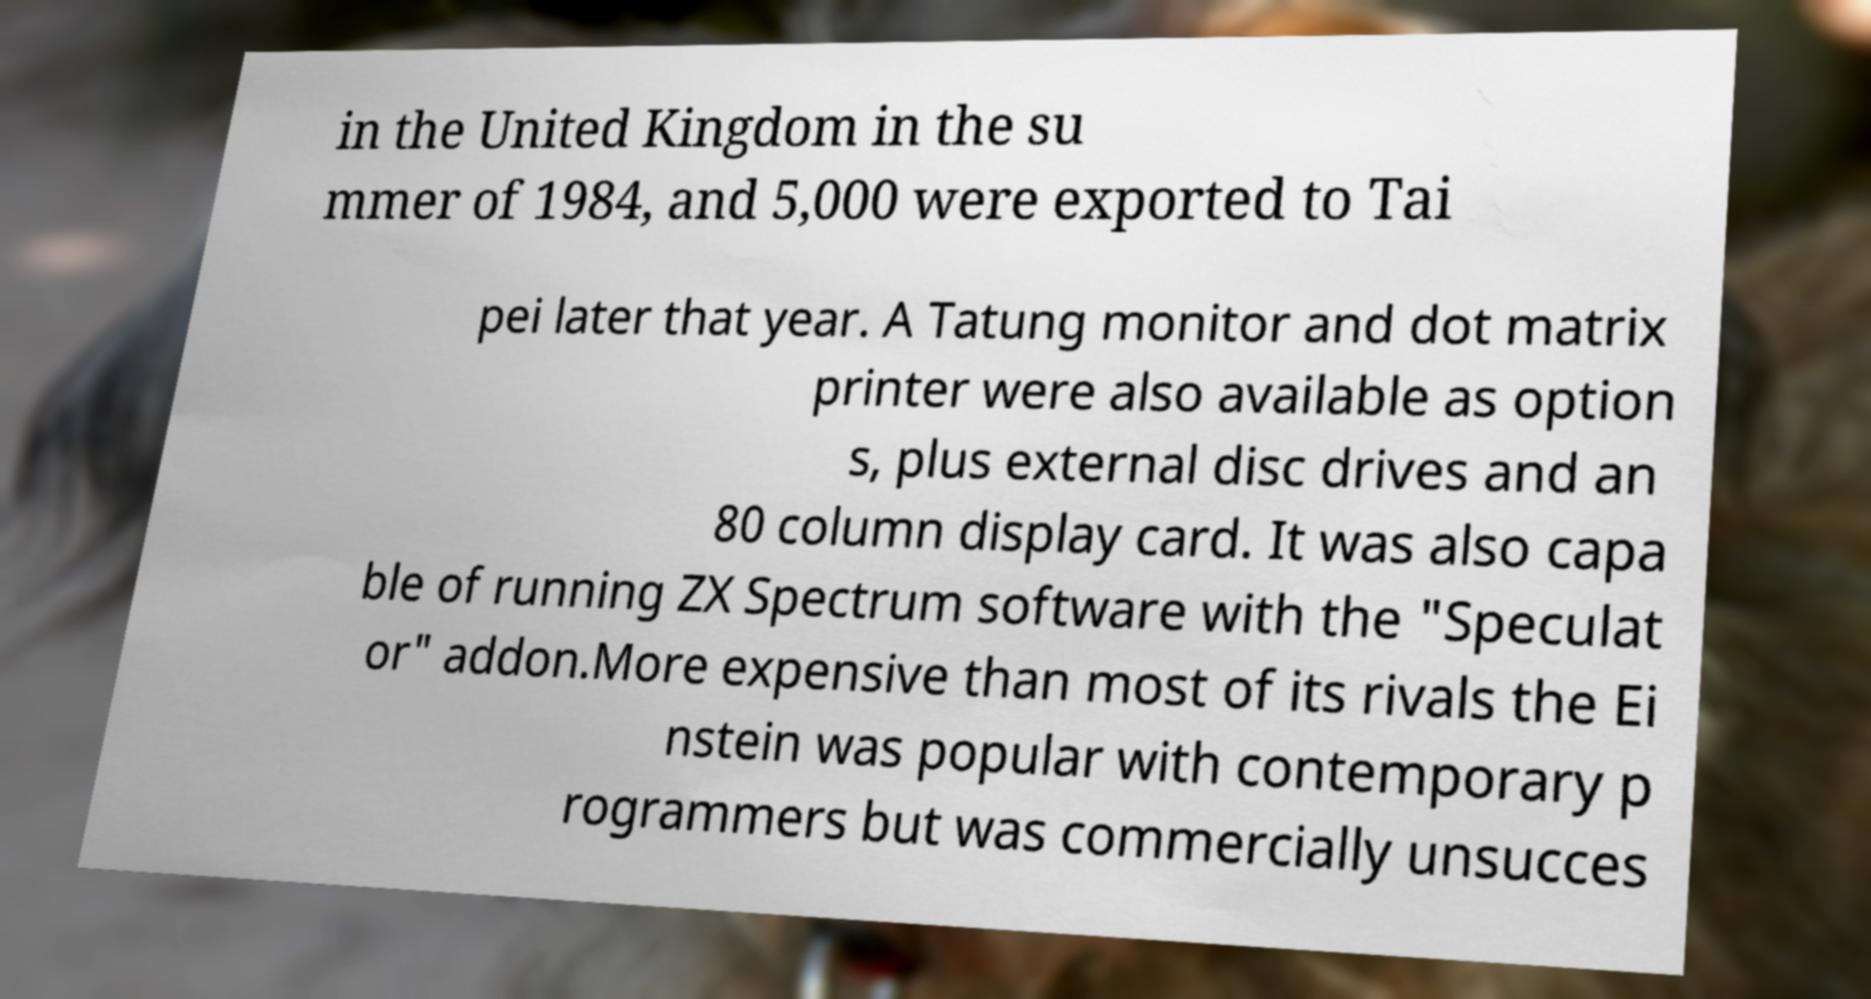I need the written content from this picture converted into text. Can you do that? in the United Kingdom in the su mmer of 1984, and 5,000 were exported to Tai pei later that year. A Tatung monitor and dot matrix printer were also available as option s, plus external disc drives and an 80 column display card. It was also capa ble of running ZX Spectrum software with the "Speculat or" addon.More expensive than most of its rivals the Ei nstein was popular with contemporary p rogrammers but was commercially unsucces 